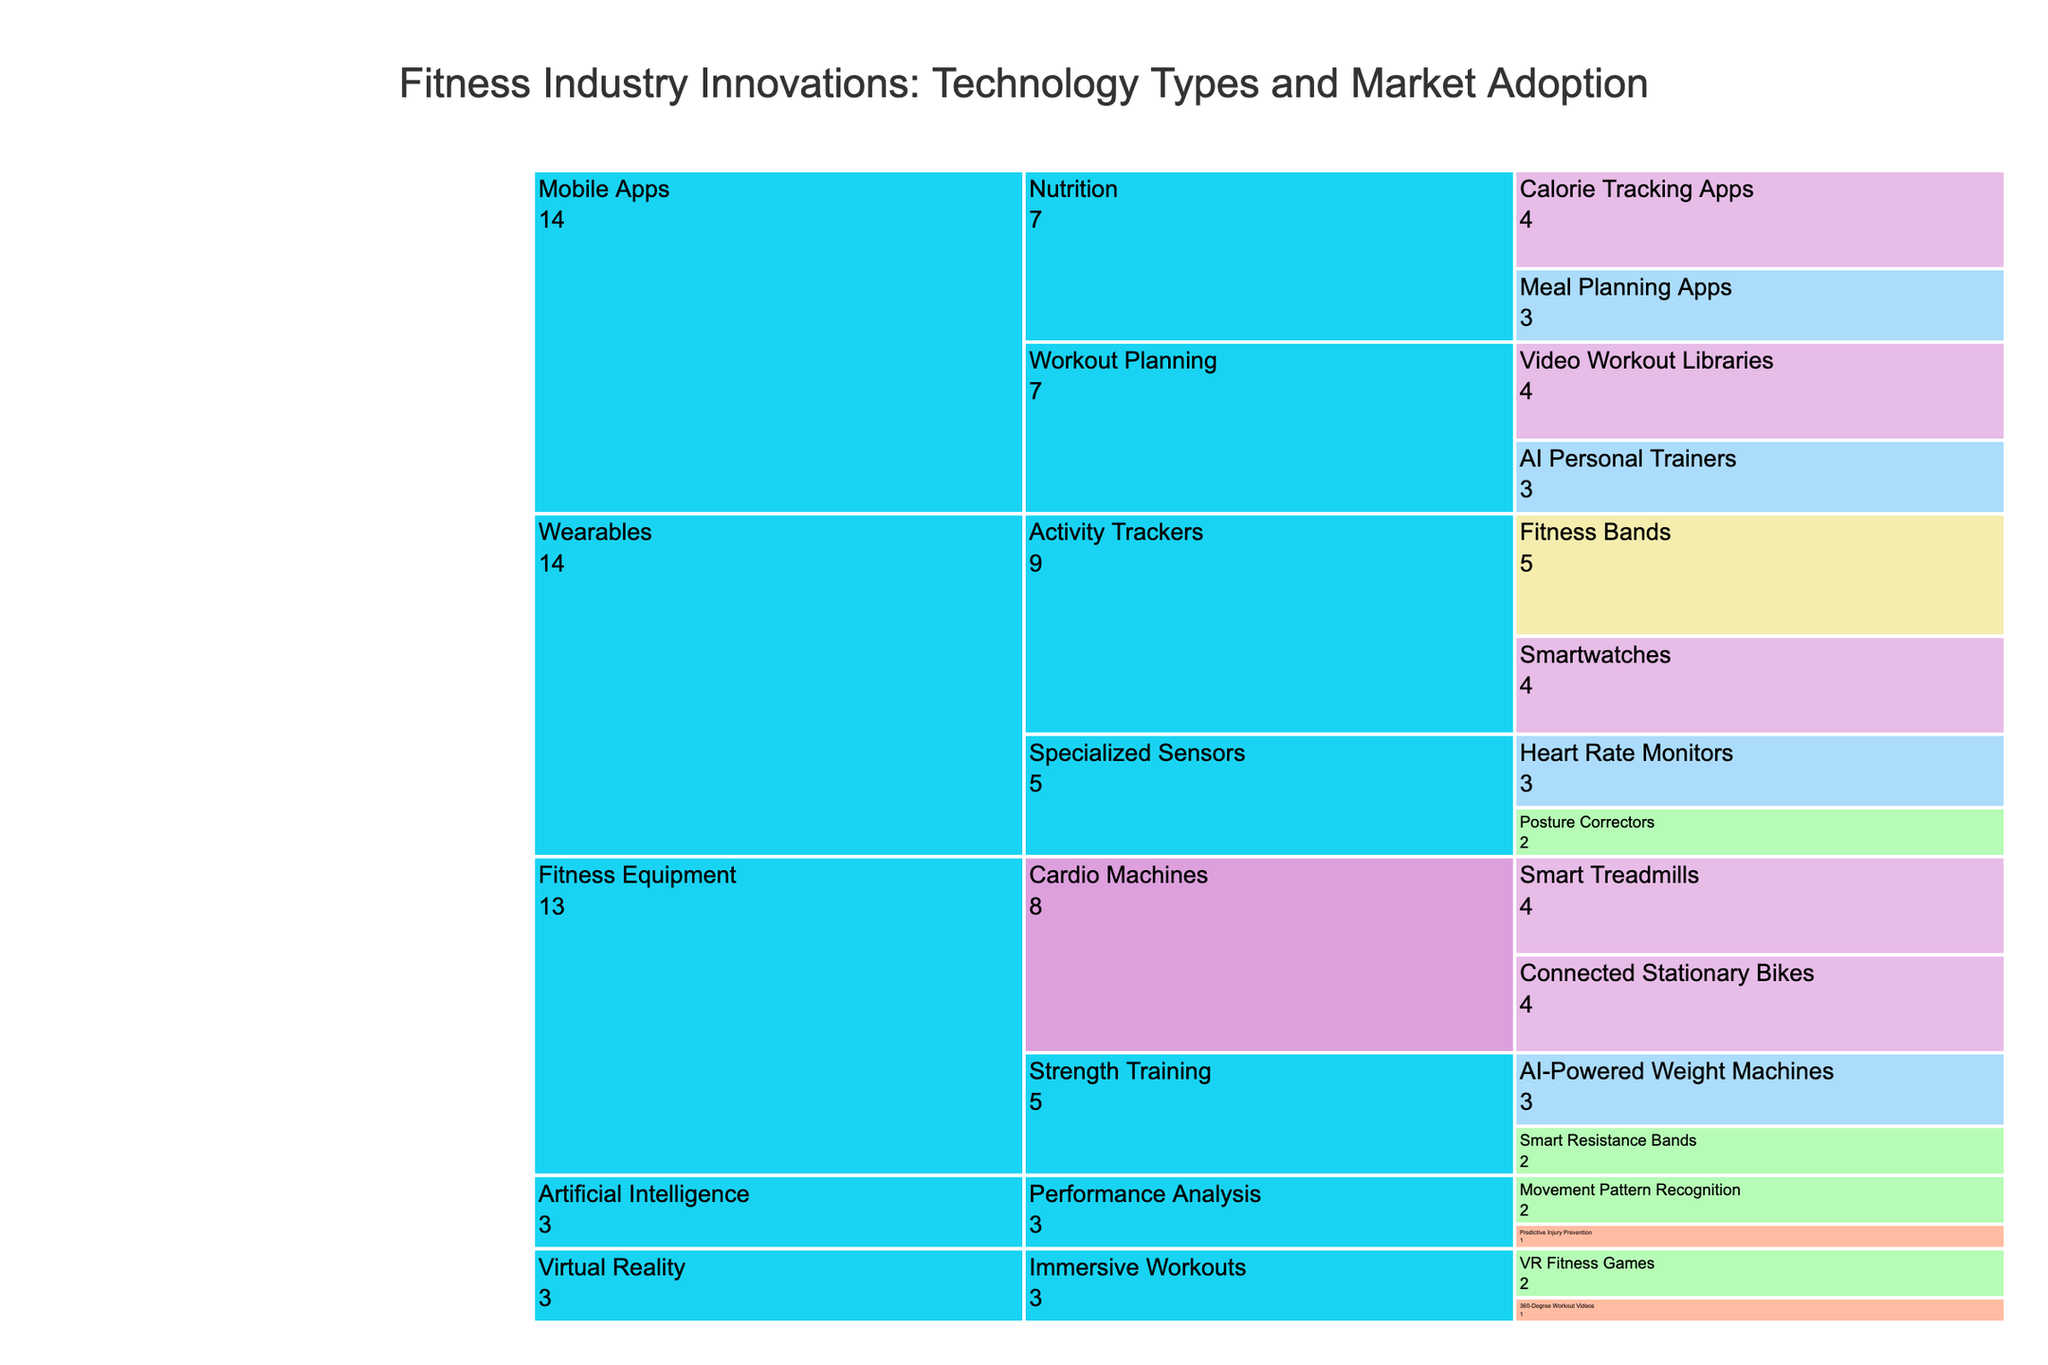What is the title of the figure? The title is usually located at the top of the figure and states the main topic covered. In this case, it is clearly visible as "Fitness Industry Innovations: Technology Types and Market Adoption".
Answer: Fitness Industry Innovations: Technology Types and Market Adoption Which category has the highest market adoption level? To determine this, observe the color coding in the chart that represents the highest adoption level, which is "Very High". The "Wearables" category has technology colored in "Khaki", indicating "Very High".
Answer: Wearables How many technologies have a "Low" adoption level? Inspect each section and count the technologies with the color that maps to "Low". Based on the data, these are "Smart Resistance Bands", "Posture Correctors", "VR Fitness Games", and "Movement Pattern Recognition", making a total of four.
Answer: 4 Which subcategory under "Fitness Equipment" has a medium adoption level? Look under the "Fitness Equipment" category and identify the subcategories. Find the technologies with "Medium" adoption. "AI-Powered Weight Machines" is under the "Strength Training" subcategory with a medium adoption level.
Answer: Strength Training Compare the number of technologies in the "Mobile Apps" and "Virtual Reality" categories. Which has more, and by how many? Count the technologies listed under "Mobile Apps" and "Virtual Reality". "Mobile Apps" has four technologies, whereas "Virtual Reality" has two. Thus, "Mobile Apps" has two more technologies.
Answer: Mobile Apps, by 2 Which technology has the highest adoption level among "Activity Trackers"? The "Activity Trackers" subcategory in the "Wearables" category has two technologies. Among "Fitness Bands" (Very High) and "Smartwatches" (High), the highest is "Fitness Bands".
Answer: Fitness Bands What is the combined adoption value for the "Virtual Reality" category? Calculate by summing the values of all technologies in the "Virtual Reality" category: "VR Fitness Games" (Low = 2) and "360-Degree Workout Videos" (Very Low = 1). Therefore, the combined value is 2 + 1 = 3.
Answer: 3 How does the adoption level of "AI Personal Trainers" compare to "Meal Planning Apps"? Under the "Mobile Apps" category, check the adoption levels of both technologies. "AI Personal Trainers" has medium adoption, while "Meal Planning Apps" also has medium adoption, so they are equal.
Answer: Equal Which subcategory under "Artificial Intelligence" has the lowest adoption level? Within the "Artificial Intelligence" category, compare the adoption levels of technologies under "Performance Analysis". "Movement Pattern Recognition" (Low) and "Predictive Injury Prevention" (Very Low). The lowest adoption level is "Predictive Injury Prevention".
Answer: Performance Analysis 